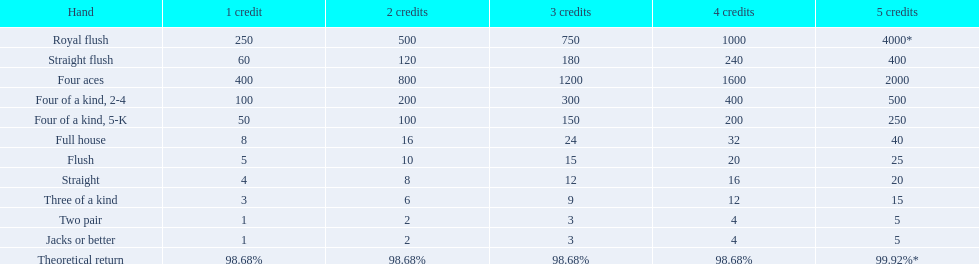Can you give me this table in json format? {'header': ['Hand', '1 credit', '2 credits', '3 credits', '4 credits', '5 credits'], 'rows': [['Royal flush', '250', '500', '750', '1000', '4000*'], ['Straight flush', '60', '120', '180', '240', '400'], ['Four aces', '400', '800', '1200', '1600', '2000'], ['Four of a kind, 2-4', '100', '200', '300', '400', '500'], ['Four of a kind, 5-K', '50', '100', '150', '200', '250'], ['Full house', '8', '16', '24', '32', '40'], ['Flush', '5', '10', '15', '20', '25'], ['Straight', '4', '8', '12', '16', '20'], ['Three of a kind', '3', '6', '9', '12', '15'], ['Two pair', '1', '2', '3', '4', '5'], ['Jacks or better', '1', '2', '3', '4', '5'], ['Theoretical return', '98.68%', '98.68%', '98.68%', '98.68%', '99.92%*']]} Can you describe the different hands? Royal flush, Straight flush, Four aces, Four of a kind, 2-4, Four of a kind, 5-K, Full house, Flush, Straight, Three of a kind, Two pair, Jacks or better, Theoretical return. Which hand has a superior rank: straights or flushes? Flush. 